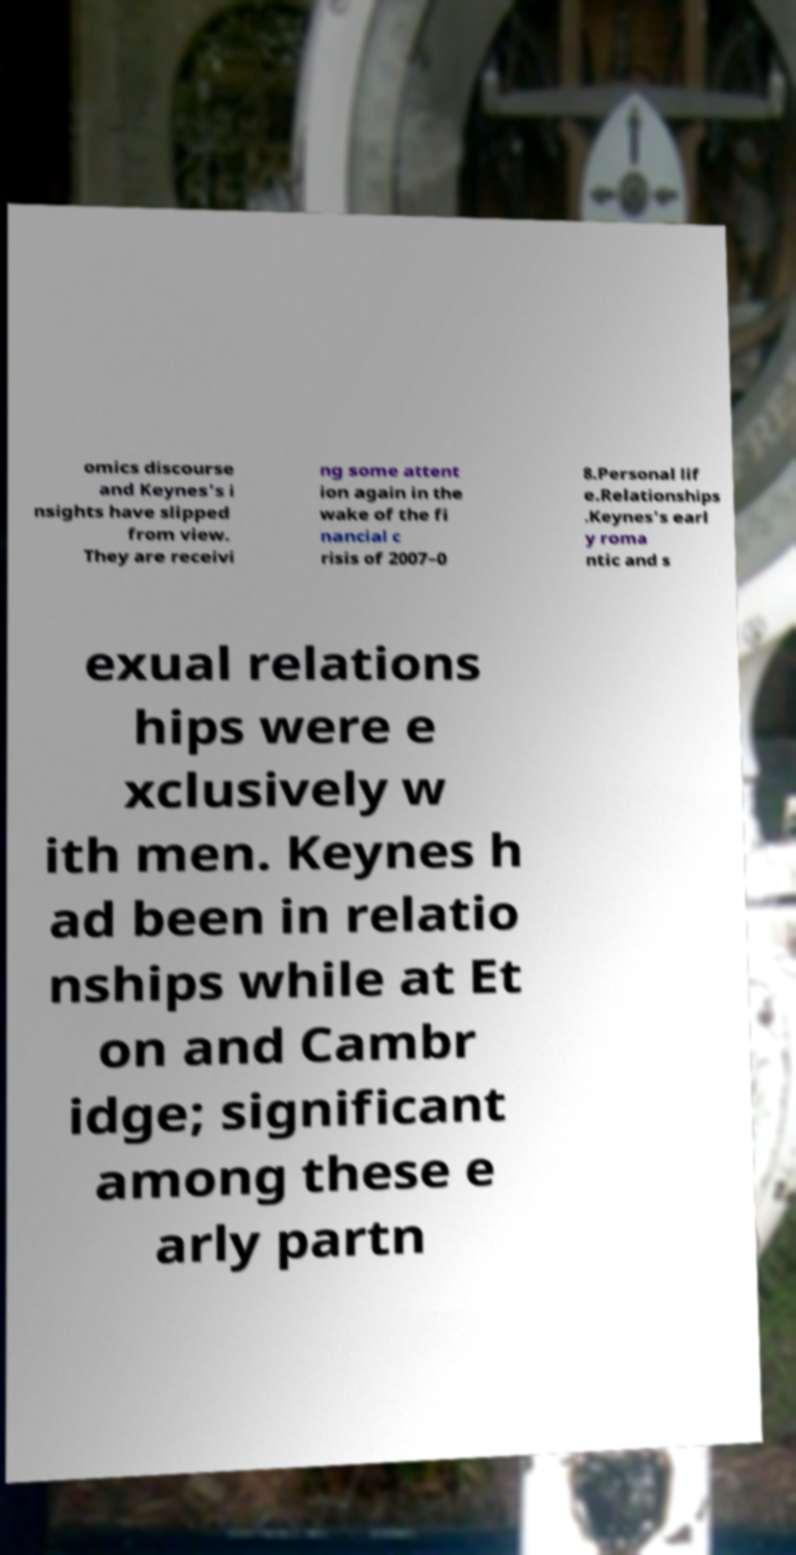Can you accurately transcribe the text from the provided image for me? omics discourse and Keynes's i nsights have slipped from view. They are receivi ng some attent ion again in the wake of the fi nancial c risis of 2007–0 8.Personal lif e.Relationships .Keynes's earl y roma ntic and s exual relations hips were e xclusively w ith men. Keynes h ad been in relatio nships while at Et on and Cambr idge; significant among these e arly partn 